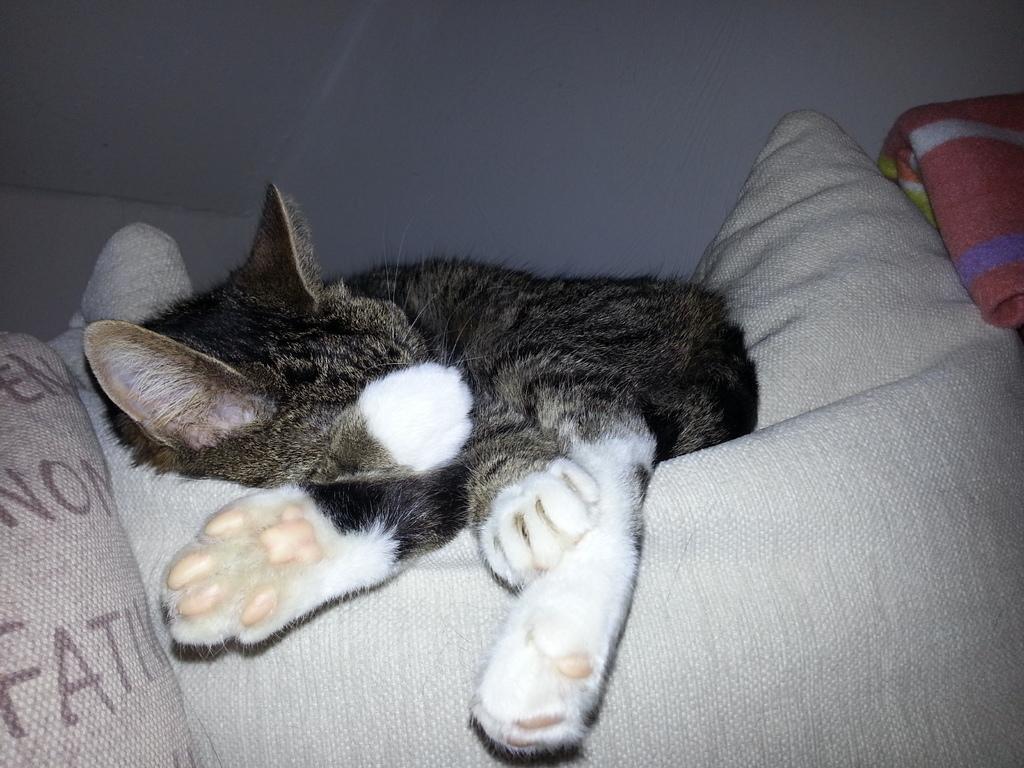Please provide a concise description of this image. In this image there is a cat in the center sleeping on the bed. 